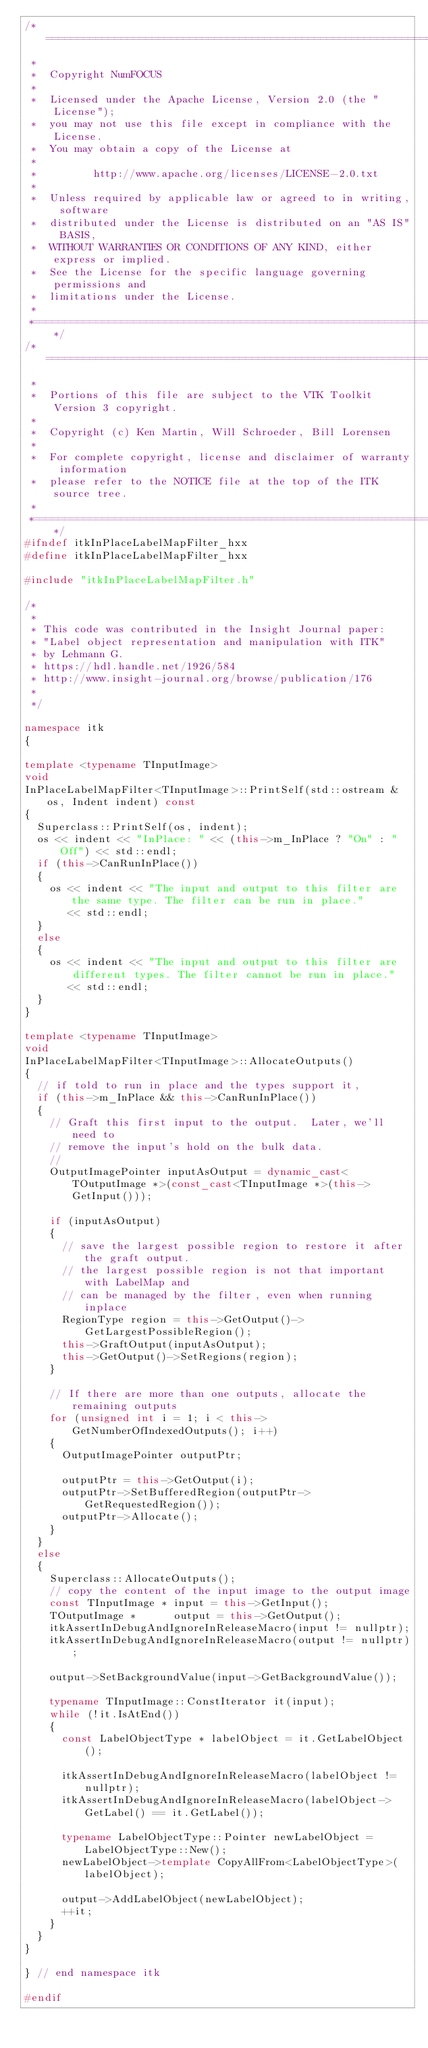<code> <loc_0><loc_0><loc_500><loc_500><_C++_>/*=========================================================================
 *
 *  Copyright NumFOCUS
 *
 *  Licensed under the Apache License, Version 2.0 (the "License");
 *  you may not use this file except in compliance with the License.
 *  You may obtain a copy of the License at
 *
 *         http://www.apache.org/licenses/LICENSE-2.0.txt
 *
 *  Unless required by applicable law or agreed to in writing, software
 *  distributed under the License is distributed on an "AS IS" BASIS,
 *  WITHOUT WARRANTIES OR CONDITIONS OF ANY KIND, either express or implied.
 *  See the License for the specific language governing permissions and
 *  limitations under the License.
 *
 *=========================================================================*/
/*=========================================================================
 *
 *  Portions of this file are subject to the VTK Toolkit Version 3 copyright.
 *
 *  Copyright (c) Ken Martin, Will Schroeder, Bill Lorensen
 *
 *  For complete copyright, license and disclaimer of warranty information
 *  please refer to the NOTICE file at the top of the ITK source tree.
 *
 *=========================================================================*/
#ifndef itkInPlaceLabelMapFilter_hxx
#define itkInPlaceLabelMapFilter_hxx

#include "itkInPlaceLabelMapFilter.h"

/*
 *
 * This code was contributed in the Insight Journal paper:
 * "Label object representation and manipulation with ITK"
 * by Lehmann G.
 * https://hdl.handle.net/1926/584
 * http://www.insight-journal.org/browse/publication/176
 *
 */

namespace itk
{

template <typename TInputImage>
void
InPlaceLabelMapFilter<TInputImage>::PrintSelf(std::ostream & os, Indent indent) const
{
  Superclass::PrintSelf(os, indent);
  os << indent << "InPlace: " << (this->m_InPlace ? "On" : "Off") << std::endl;
  if (this->CanRunInPlace())
  {
    os << indent << "The input and output to this filter are the same type. The filter can be run in place."
       << std::endl;
  }
  else
  {
    os << indent << "The input and output to this filter are different types. The filter cannot be run in place."
       << std::endl;
  }
}

template <typename TInputImage>
void
InPlaceLabelMapFilter<TInputImage>::AllocateOutputs()
{
  // if told to run in place and the types support it,
  if (this->m_InPlace && this->CanRunInPlace())
  {
    // Graft this first input to the output.  Later, we'll need to
    // remove the input's hold on the bulk data.
    //
    OutputImagePointer inputAsOutput = dynamic_cast<TOutputImage *>(const_cast<TInputImage *>(this->GetInput()));

    if (inputAsOutput)
    {
      // save the largest possible region to restore it after the graft output.
      // the largest possible region is not that important with LabelMap and
      // can be managed by the filter, even when running inplace
      RegionType region = this->GetOutput()->GetLargestPossibleRegion();
      this->GraftOutput(inputAsOutput);
      this->GetOutput()->SetRegions(region);
    }

    // If there are more than one outputs, allocate the remaining outputs
    for (unsigned int i = 1; i < this->GetNumberOfIndexedOutputs(); i++)
    {
      OutputImagePointer outputPtr;

      outputPtr = this->GetOutput(i);
      outputPtr->SetBufferedRegion(outputPtr->GetRequestedRegion());
      outputPtr->Allocate();
    }
  }
  else
  {
    Superclass::AllocateOutputs();
    // copy the content of the input image to the output image
    const TInputImage * input = this->GetInput();
    TOutputImage *      output = this->GetOutput();
    itkAssertInDebugAndIgnoreInReleaseMacro(input != nullptr);
    itkAssertInDebugAndIgnoreInReleaseMacro(output != nullptr);

    output->SetBackgroundValue(input->GetBackgroundValue());

    typename TInputImage::ConstIterator it(input);
    while (!it.IsAtEnd())
    {
      const LabelObjectType * labelObject = it.GetLabelObject();

      itkAssertInDebugAndIgnoreInReleaseMacro(labelObject != nullptr);
      itkAssertInDebugAndIgnoreInReleaseMacro(labelObject->GetLabel() == it.GetLabel());

      typename LabelObjectType::Pointer newLabelObject = LabelObjectType::New();
      newLabelObject->template CopyAllFrom<LabelObjectType>(labelObject);

      output->AddLabelObject(newLabelObject);
      ++it;
    }
  }
}

} // end namespace itk

#endif
</code> 